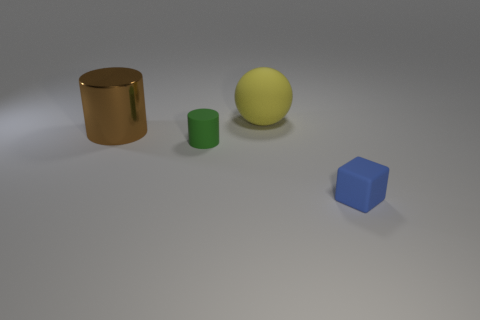There is a small thing in front of the cylinder in front of the cylinder that is behind the green object; what is its color?
Offer a very short reply. Blue. There is another object that is the same size as the yellow matte object; what is its color?
Keep it short and to the point. Brown. There is a small rubber object that is behind the tiny object in front of the small thing that is on the left side of the tiny blue object; what is its shape?
Your response must be concise. Cylinder. What number of things are big metal blocks or rubber objects in front of the small green cylinder?
Ensure brevity in your answer.  1. There is a rubber object that is to the left of the matte ball; does it have the same size as the big brown metal cylinder?
Ensure brevity in your answer.  No. There is a large object that is on the right side of the large metal cylinder; what is it made of?
Your answer should be compact. Rubber. Are there the same number of large yellow balls that are in front of the large yellow object and big brown things in front of the tiny green matte thing?
Your answer should be compact. Yes. What color is the tiny rubber thing that is the same shape as the shiny thing?
Offer a very short reply. Green. Is there anything else that is the same color as the ball?
Offer a very short reply. No. How many matte things are big balls or small gray balls?
Provide a short and direct response. 1. 